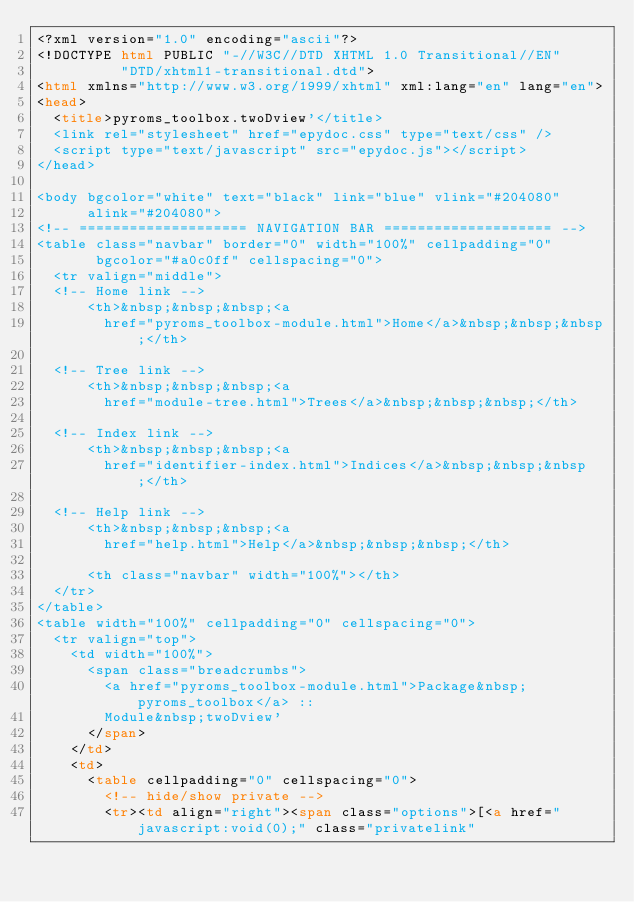<code> <loc_0><loc_0><loc_500><loc_500><_HTML_><?xml version="1.0" encoding="ascii"?>
<!DOCTYPE html PUBLIC "-//W3C//DTD XHTML 1.0 Transitional//EN"
          "DTD/xhtml1-transitional.dtd">
<html xmlns="http://www.w3.org/1999/xhtml" xml:lang="en" lang="en">
<head>
  <title>pyroms_toolbox.twoDview'</title>
  <link rel="stylesheet" href="epydoc.css" type="text/css" />
  <script type="text/javascript" src="epydoc.js"></script>
</head>

<body bgcolor="white" text="black" link="blue" vlink="#204080"
      alink="#204080">
<!-- ==================== NAVIGATION BAR ==================== -->
<table class="navbar" border="0" width="100%" cellpadding="0"
       bgcolor="#a0c0ff" cellspacing="0">
  <tr valign="middle">
  <!-- Home link -->
      <th>&nbsp;&nbsp;&nbsp;<a
        href="pyroms_toolbox-module.html">Home</a>&nbsp;&nbsp;&nbsp;</th>

  <!-- Tree link -->
      <th>&nbsp;&nbsp;&nbsp;<a
        href="module-tree.html">Trees</a>&nbsp;&nbsp;&nbsp;</th>

  <!-- Index link -->
      <th>&nbsp;&nbsp;&nbsp;<a
        href="identifier-index.html">Indices</a>&nbsp;&nbsp;&nbsp;</th>

  <!-- Help link -->
      <th>&nbsp;&nbsp;&nbsp;<a
        href="help.html">Help</a>&nbsp;&nbsp;&nbsp;</th>

      <th class="navbar" width="100%"></th>
  </tr>
</table>
<table width="100%" cellpadding="0" cellspacing="0">
  <tr valign="top">
    <td width="100%">
      <span class="breadcrumbs">
        <a href="pyroms_toolbox-module.html">Package&nbsp;pyroms_toolbox</a> ::
        Module&nbsp;twoDview'
      </span>
    </td>
    <td>
      <table cellpadding="0" cellspacing="0">
        <!-- hide/show private -->
        <tr><td align="right"><span class="options">[<a href="javascript:void(0);" class="privatelink"</code> 